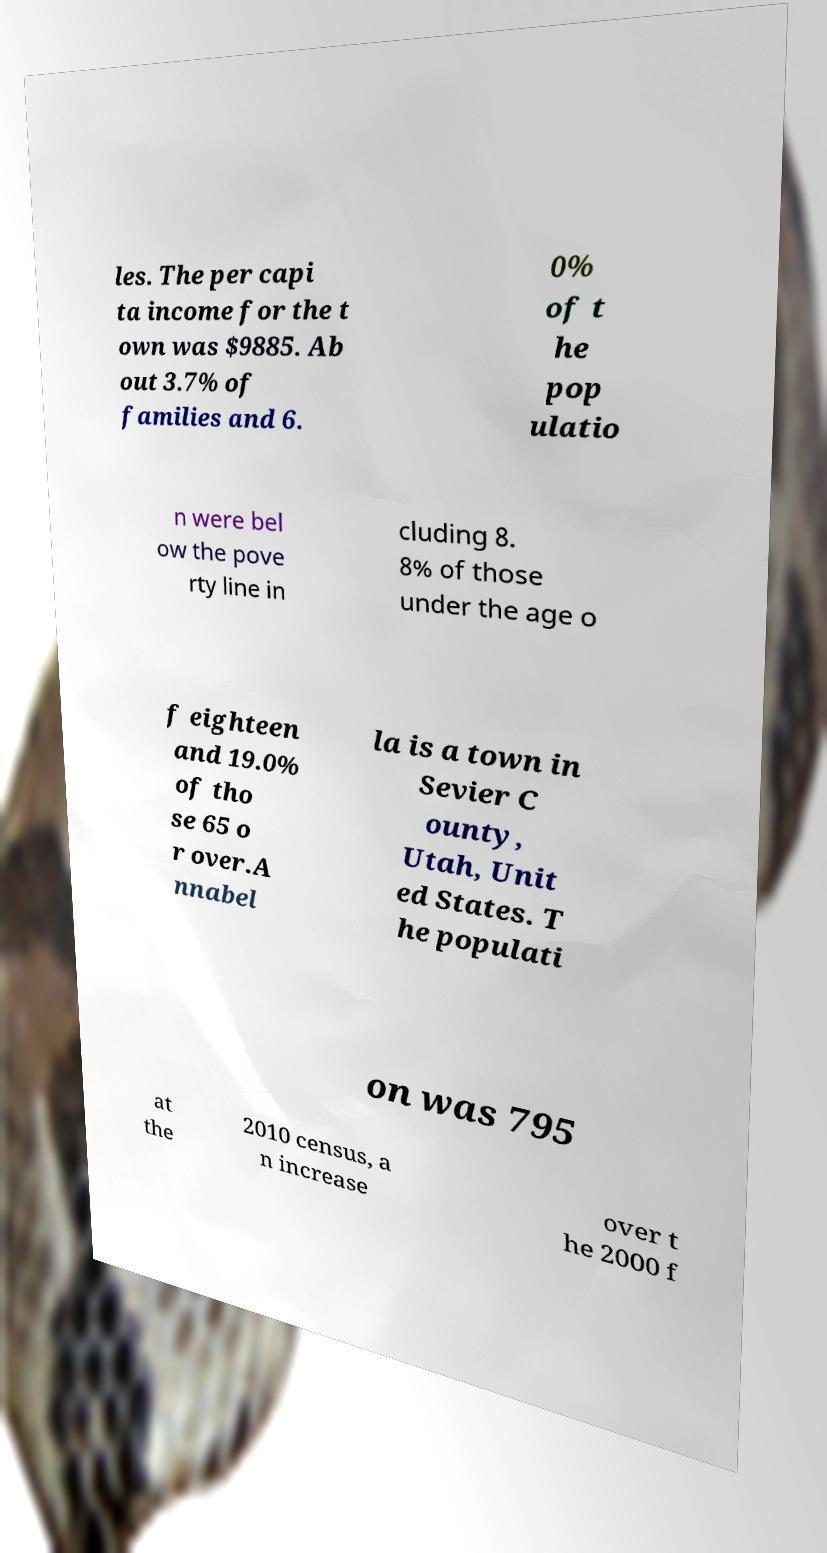I need the written content from this picture converted into text. Can you do that? les. The per capi ta income for the t own was $9885. Ab out 3.7% of families and 6. 0% of t he pop ulatio n were bel ow the pove rty line in cluding 8. 8% of those under the age o f eighteen and 19.0% of tho se 65 o r over.A nnabel la is a town in Sevier C ounty, Utah, Unit ed States. T he populati on was 795 at the 2010 census, a n increase over t he 2000 f 